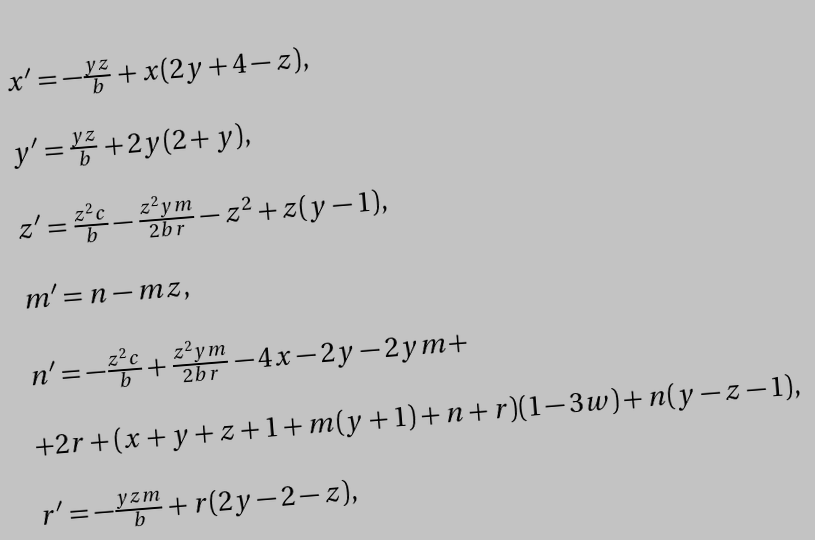<formula> <loc_0><loc_0><loc_500><loc_500>\begin{array} { l } x ^ { \prime } = - \frac { y z } { b } + x ( 2 y + 4 - z ) , \\ \\ y ^ { \prime } = \frac { y z } { b } + 2 y ( 2 + y ) , \\ \\ z ^ { \prime } = \frac { z ^ { 2 } c } { b } - \frac { z ^ { 2 } y m } { 2 b r } - z ^ { 2 } + z ( y - 1 ) , \\ \\ m ^ { \prime } = n - m z , \\ \\ n ^ { \prime } = - \frac { z ^ { 2 } c } { b } + \frac { z ^ { 2 } y m } { 2 b r } - 4 x - 2 y - 2 y m + \\ \\ + 2 r + ( x + y + z + 1 + m ( y + 1 ) + n + r ) ( 1 - 3 w ) + n ( y - z - 1 ) , \\ \\ r ^ { \prime } = - \frac { y z m } { b } + r ( 2 y - 2 - z ) , \end{array}</formula> 